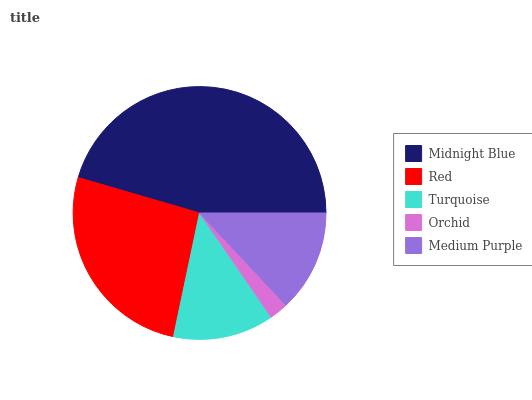Is Orchid the minimum?
Answer yes or no. Yes. Is Midnight Blue the maximum?
Answer yes or no. Yes. Is Red the minimum?
Answer yes or no. No. Is Red the maximum?
Answer yes or no. No. Is Midnight Blue greater than Red?
Answer yes or no. Yes. Is Red less than Midnight Blue?
Answer yes or no. Yes. Is Red greater than Midnight Blue?
Answer yes or no. No. Is Midnight Blue less than Red?
Answer yes or no. No. Is Medium Purple the high median?
Answer yes or no. Yes. Is Medium Purple the low median?
Answer yes or no. Yes. Is Midnight Blue the high median?
Answer yes or no. No. Is Midnight Blue the low median?
Answer yes or no. No. 